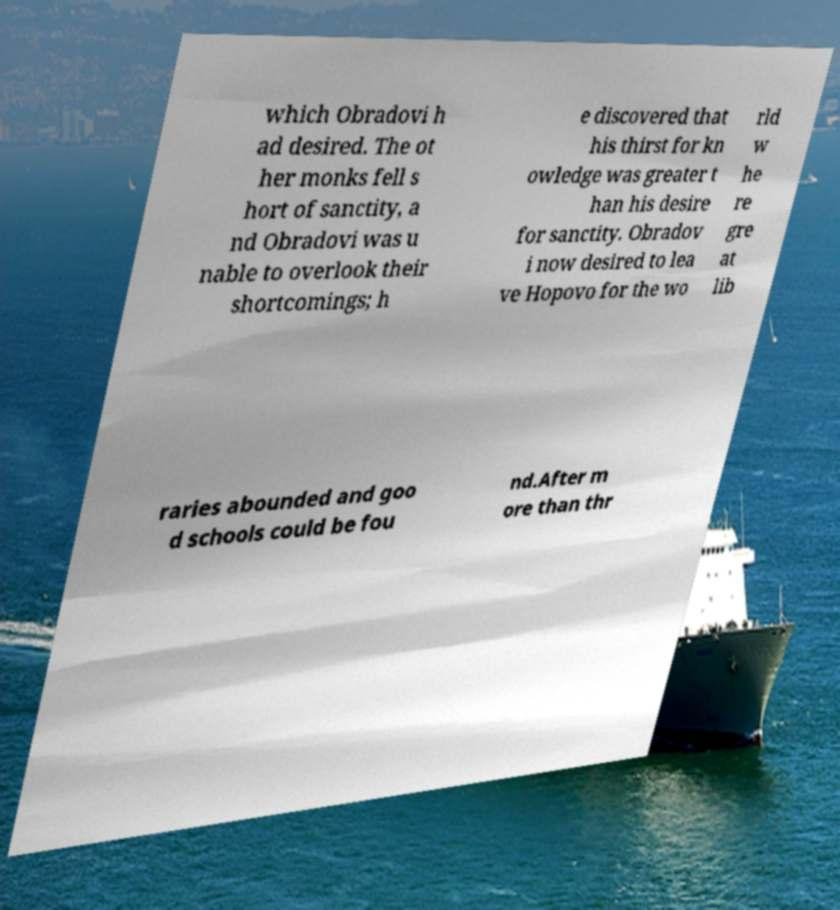For documentation purposes, I need the text within this image transcribed. Could you provide that? which Obradovi h ad desired. The ot her monks fell s hort of sanctity, a nd Obradovi was u nable to overlook their shortcomings; h e discovered that his thirst for kn owledge was greater t han his desire for sanctity. Obradov i now desired to lea ve Hopovo for the wo rld w he re gre at lib raries abounded and goo d schools could be fou nd.After m ore than thr 